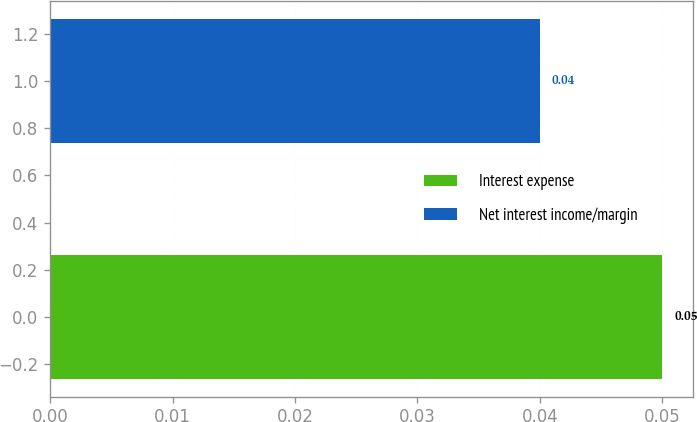Convert chart. <chart><loc_0><loc_0><loc_500><loc_500><bar_chart><fcel>Interest expense<fcel>Net interest income/margin<nl><fcel>0.05<fcel>0.04<nl></chart> 